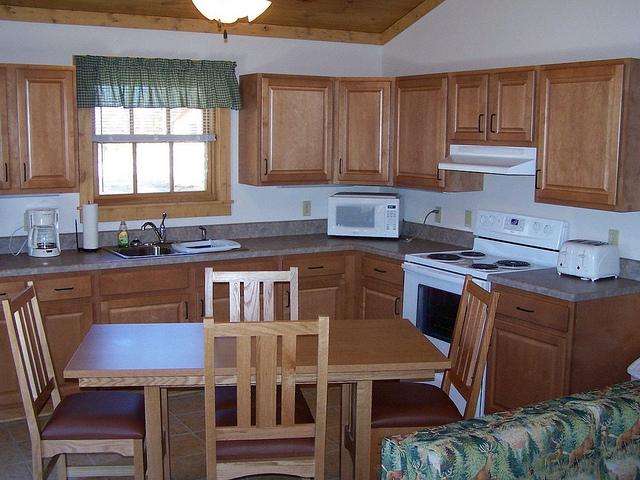Is there any coffee in the coffee maker?
Quick response, please. Yes. How many people can site at a time here?
Write a very short answer. 4. What color are the appliances?
Write a very short answer. White. Does the table and chairs match the cabinets?
Short answer required. Yes. Is the table set?
Keep it brief. No. 